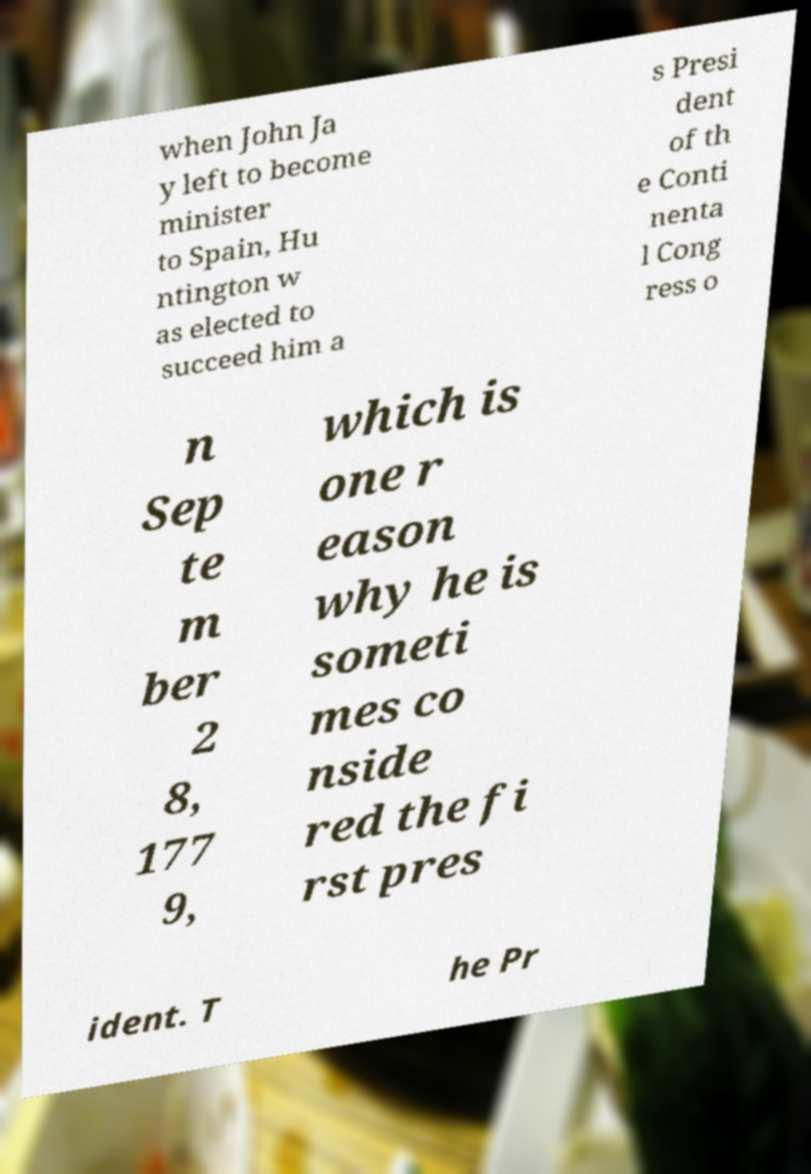There's text embedded in this image that I need extracted. Can you transcribe it verbatim? when John Ja y left to become minister to Spain, Hu ntington w as elected to succeed him a s Presi dent of th e Conti nenta l Cong ress o n Sep te m ber 2 8, 177 9, which is one r eason why he is someti mes co nside red the fi rst pres ident. T he Pr 